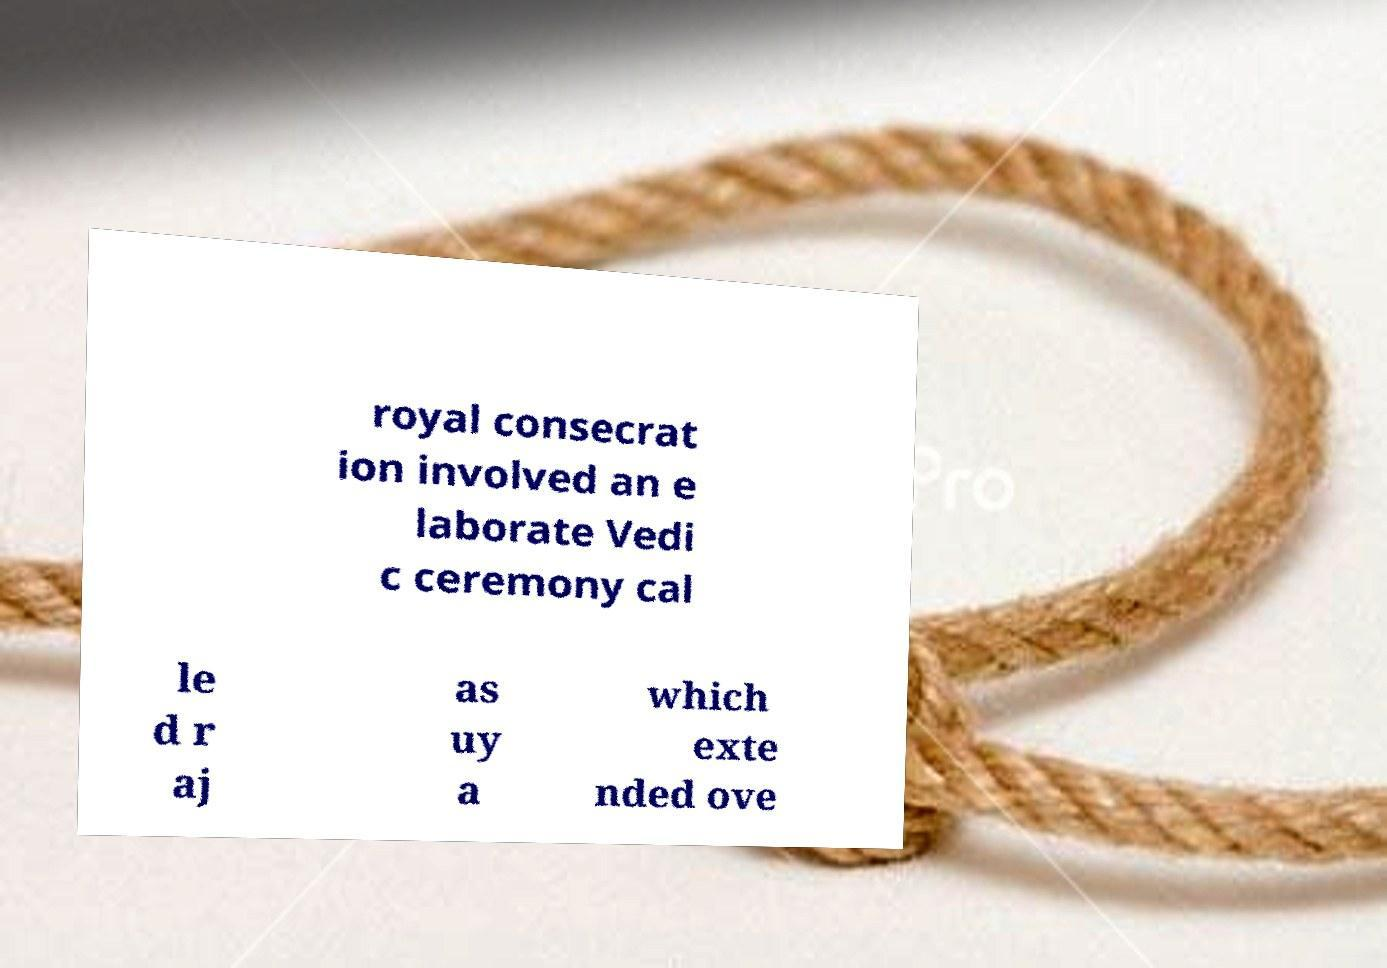Can you accurately transcribe the text from the provided image for me? royal consecrat ion involved an e laborate Vedi c ceremony cal le d r aj as uy a which exte nded ove 